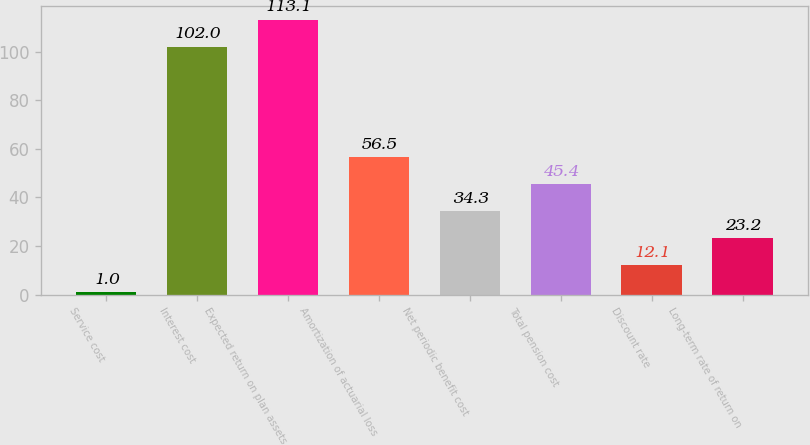Convert chart. <chart><loc_0><loc_0><loc_500><loc_500><bar_chart><fcel>Service cost<fcel>Interest cost<fcel>Expected return on plan assets<fcel>Amortization of actuarial loss<fcel>Net periodic benefit cost<fcel>Total pension cost<fcel>Discount rate<fcel>Long-term rate of return on<nl><fcel>1<fcel>102<fcel>113.1<fcel>56.5<fcel>34.3<fcel>45.4<fcel>12.1<fcel>23.2<nl></chart> 